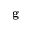<formula> <loc_0><loc_0><loc_500><loc_500>g</formula> 